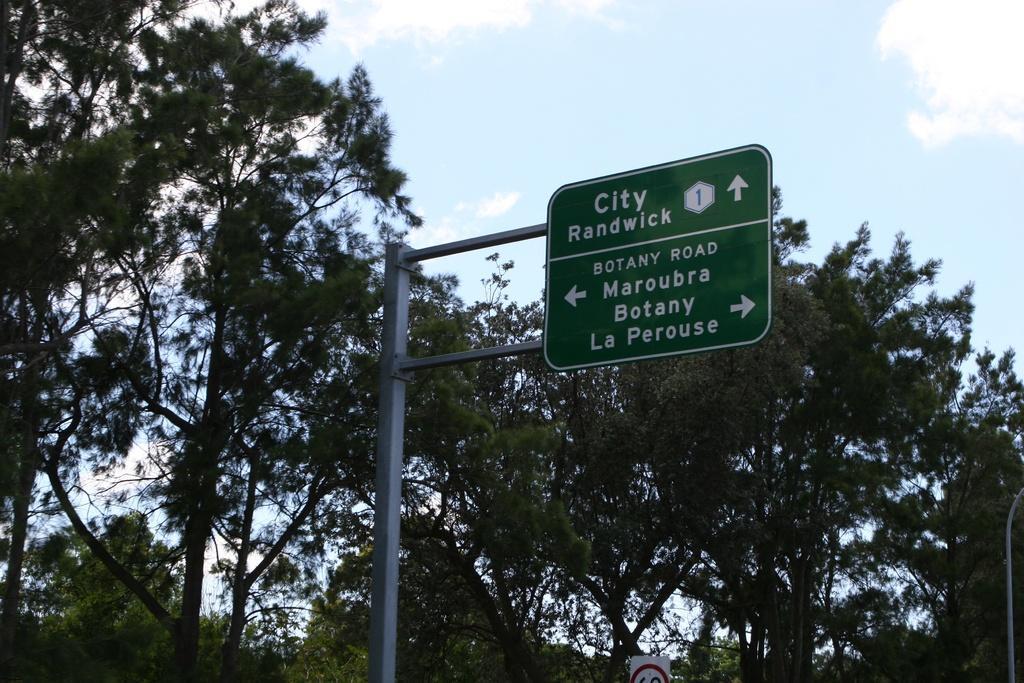Please provide a concise description of this image. In this image I can see a board attached to the pole and the board is in green color. Background I can see trees in green color and the sky is in white and blue color. 